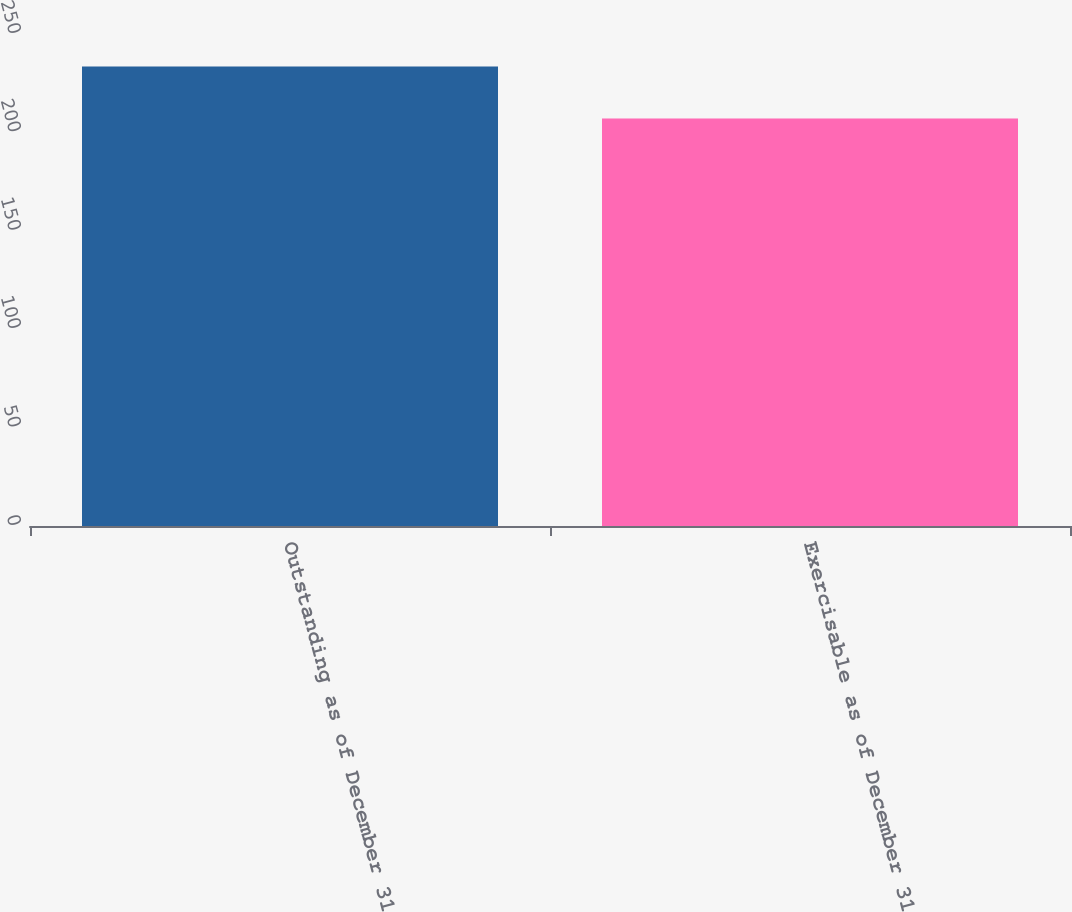Convert chart to OTSL. <chart><loc_0><loc_0><loc_500><loc_500><bar_chart><fcel>Outstanding as of December 31<fcel>Exercisable as of December 31<nl><fcel>233.5<fcel>207<nl></chart> 